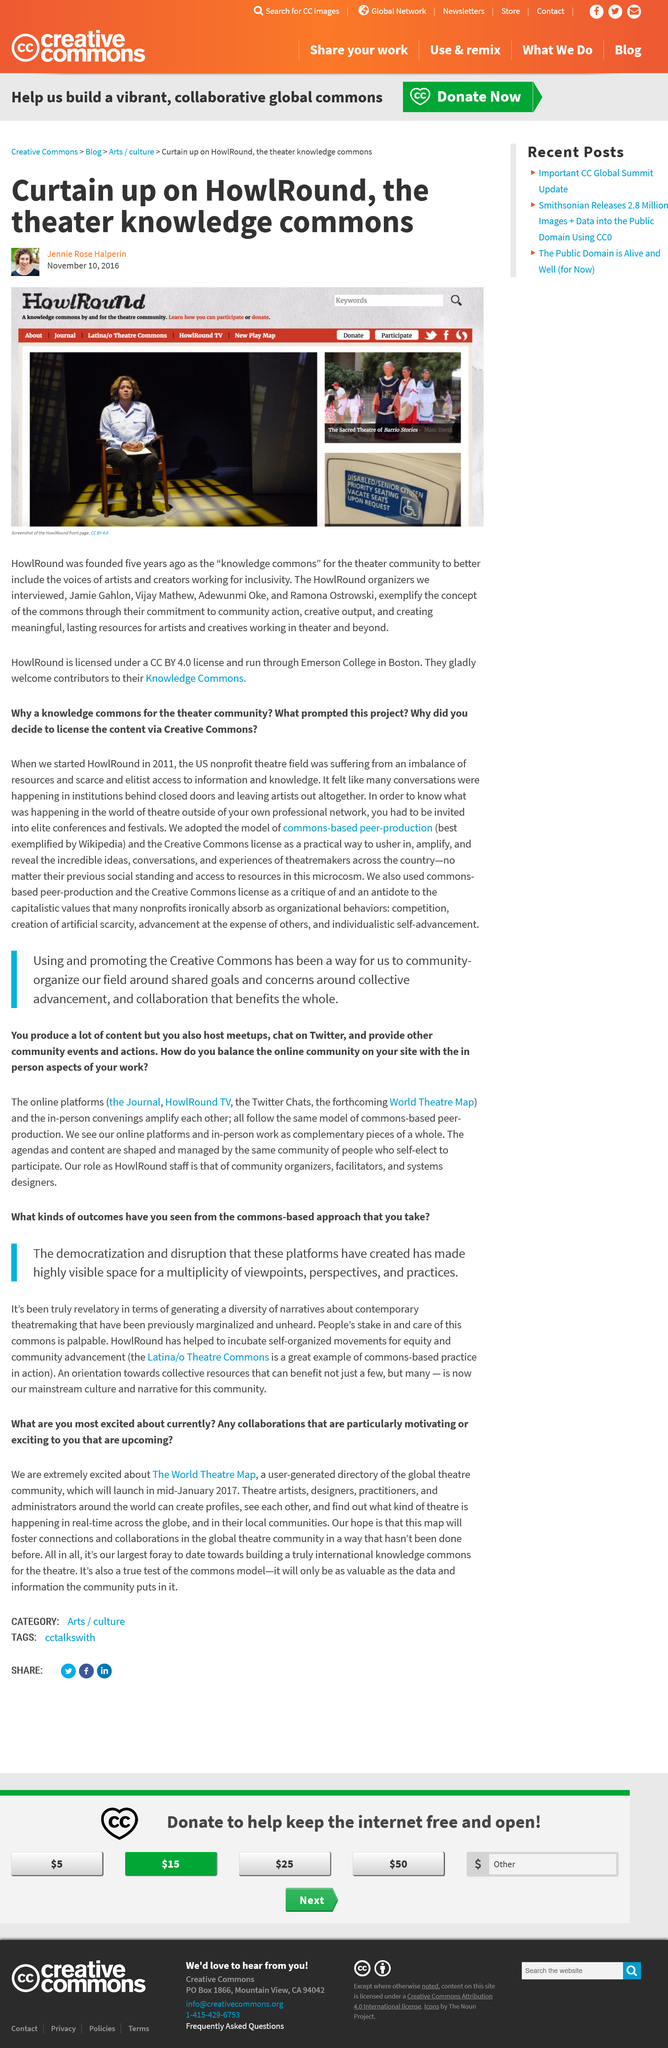Draw attention to some important aspects in this diagram. The concept of collective resources is now widely recognized and accepted in mainstream culture. The author of this article is Jennie Rose Halperin. By using the Creative Commons approach, a highly visible space for a multiplicity of viewpoints, perspectives, and practices is created. Five years ago, HowlRound was founded, and since then it has become a leading platform for theater makers and enthusiasts. This article was written on November 10, 2016, as declared in its content. 